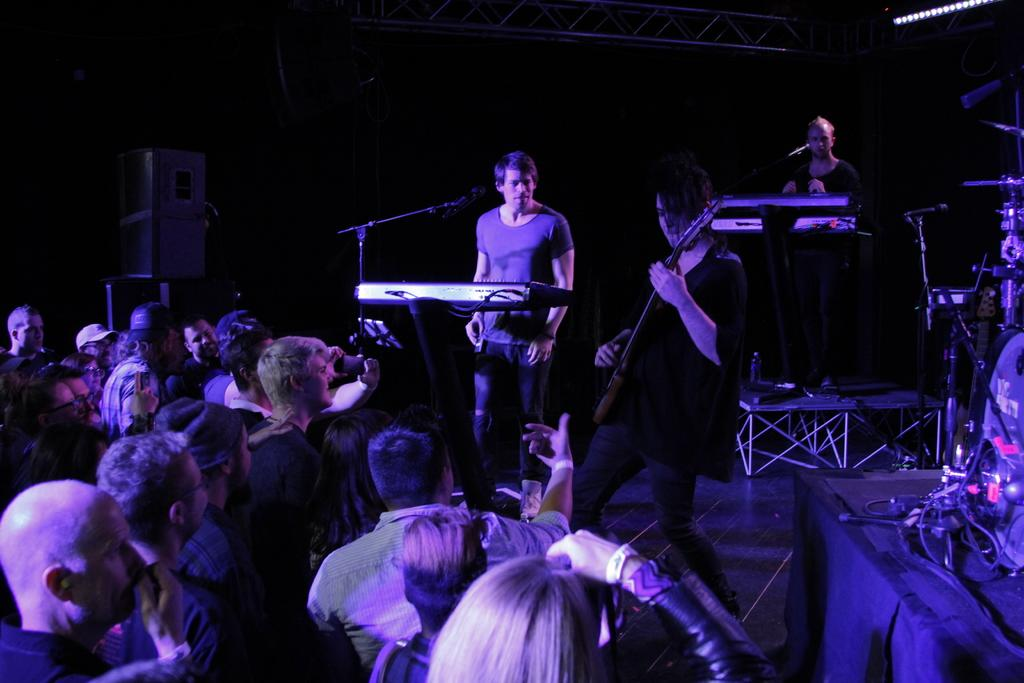What are the people in the image doing? Some people are playing musical instruments. What objects are present in the image that are related to the musical instruments? There are microphones and stands in the image. What is the color of the background in the image? The background of the image is black. What type of glove is being used for teaching in the image? There is no glove or teaching activity present in the image. 